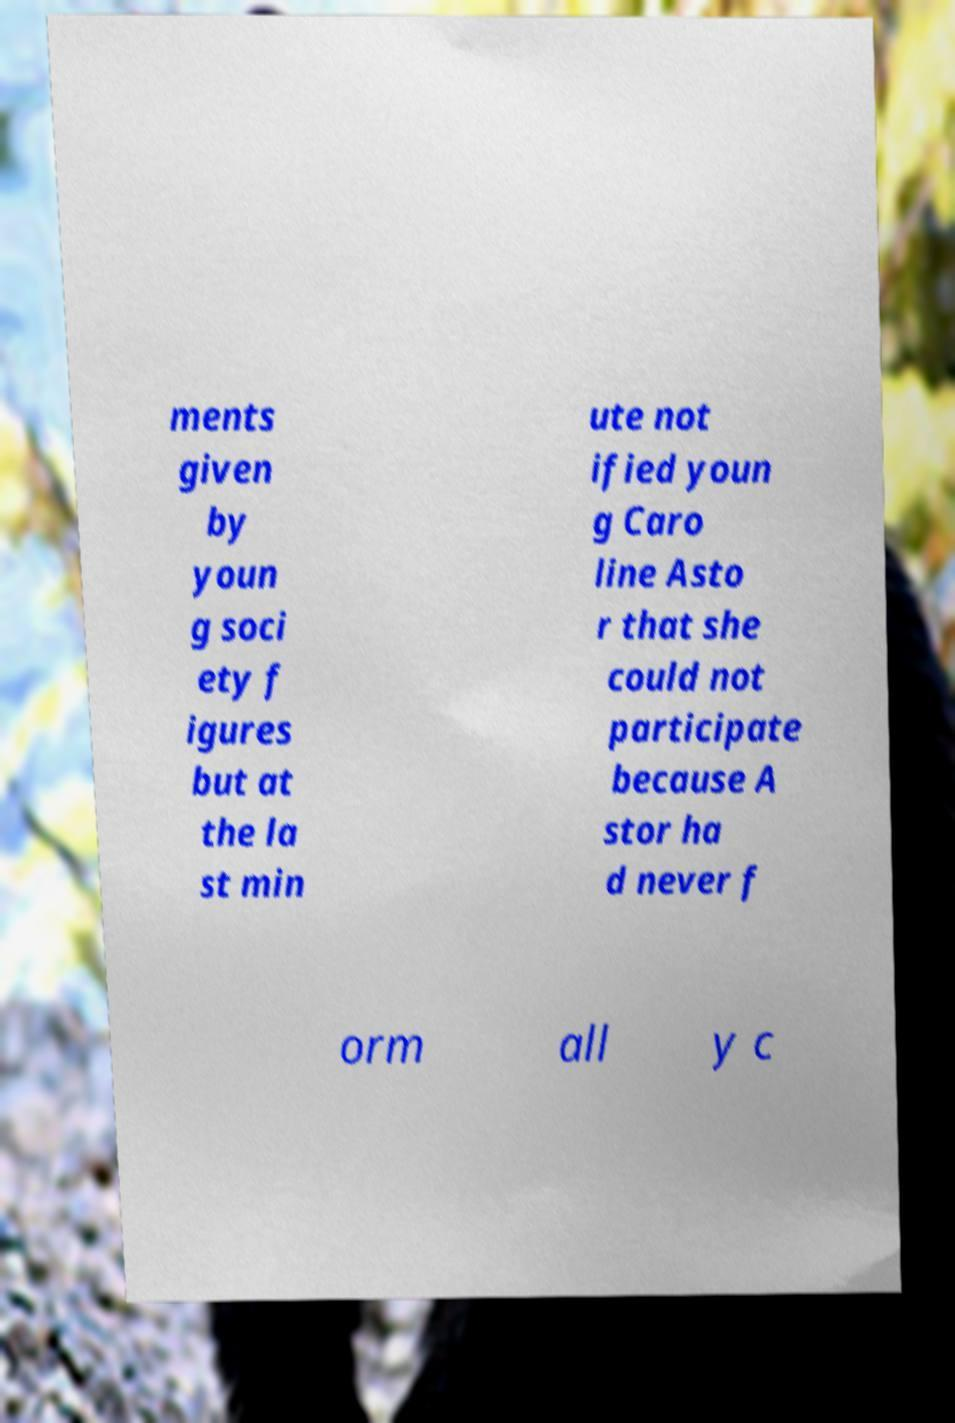Can you read and provide the text displayed in the image?This photo seems to have some interesting text. Can you extract and type it out for me? ments given by youn g soci ety f igures but at the la st min ute not ified youn g Caro line Asto r that she could not participate because A stor ha d never f orm all y c 